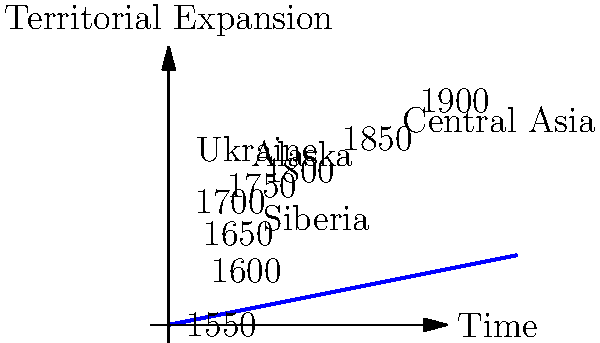In the spiral plot representing the expansion of the Russian Empire over time, which territorial acquisition is shown to have occurred earliest, and approximately during which time period? To answer this question, we need to analyze the spiral plot carefully:

1. The spiral plot represents time progressing outward from the center.
2. Each full rotation represents a century, with labels indicating the years from 1550 to 1900.
3. Territorial acquisitions are labeled along the spiral.

Examining the plot:

1. Siberia is the closest labeled territory to the center of the spiral.
2. Its position on the spiral corresponds to approximately 1.5 rotations from the 1550 starting point.
3. Each full rotation represents 100 years, so 1.5 rotations would be about 150 years after 1550.
4. This places the acquisition of Siberia around 1700.

Comparing with other labeled territories:
- Ukraine appears later on the spiral, around 2.5 rotations (circa 1800).
- Alaska and Central Asia are even further out, indicating later acquisitions.

Therefore, among the labeled territories, Siberia is shown to have been acquired earliest, approximately in the early 18th century.
Answer: Siberia, early 18th century 